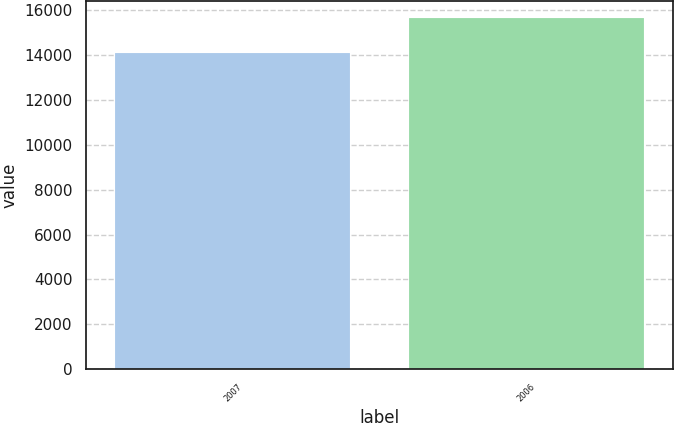Convert chart. <chart><loc_0><loc_0><loc_500><loc_500><bar_chart><fcel>2007<fcel>2006<nl><fcel>14071<fcel>15633<nl></chart> 